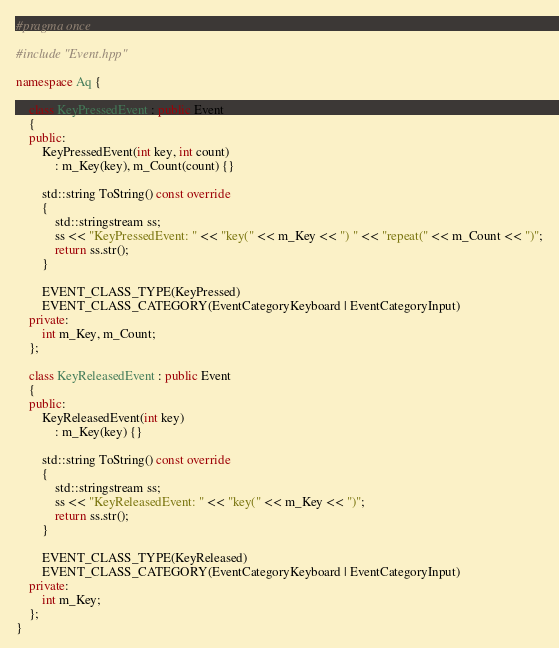<code> <loc_0><loc_0><loc_500><loc_500><_C++_>#pragma once

#include "Event.hpp"

namespace Aq {

	class KeyPressedEvent : public Event
	{
	public:
		KeyPressedEvent(int key, int count)
			: m_Key(key), m_Count(count) {}

		std::string ToString() const override
		{
			std::stringstream ss;
			ss << "KeyPressedEvent: " << "key(" << m_Key << ") " << "repeat(" << m_Count << ")";
			return ss.str();
		}

		EVENT_CLASS_TYPE(KeyPressed)
		EVENT_CLASS_CATEGORY(EventCategoryKeyboard | EventCategoryInput)
	private:
		int m_Key, m_Count;
	};

	class KeyReleasedEvent : public Event
	{
	public:
		KeyReleasedEvent(int key)
			: m_Key(key) {}

		std::string ToString() const override
		{
			std::stringstream ss;
			ss << "KeyReleasedEvent: " << "key(" << m_Key << ")";
			return ss.str();
		}

		EVENT_CLASS_TYPE(KeyReleased)
		EVENT_CLASS_CATEGORY(EventCategoryKeyboard | EventCategoryInput)
	private:
		int m_Key;
	};
}</code> 